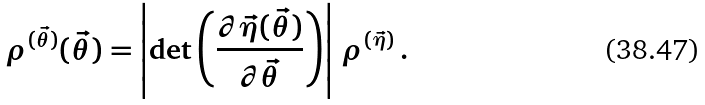<formula> <loc_0><loc_0><loc_500><loc_500>\rho ^ { ( \vec { \theta } ) } ( \vec { \theta } ) = \left | \det \left ( \frac { \partial \vec { \eta } ( \vec { \theta } ) } { \partial \vec { \theta } } \right ) \right | \, \rho ^ { ( \vec { \eta } ) } \, .</formula> 